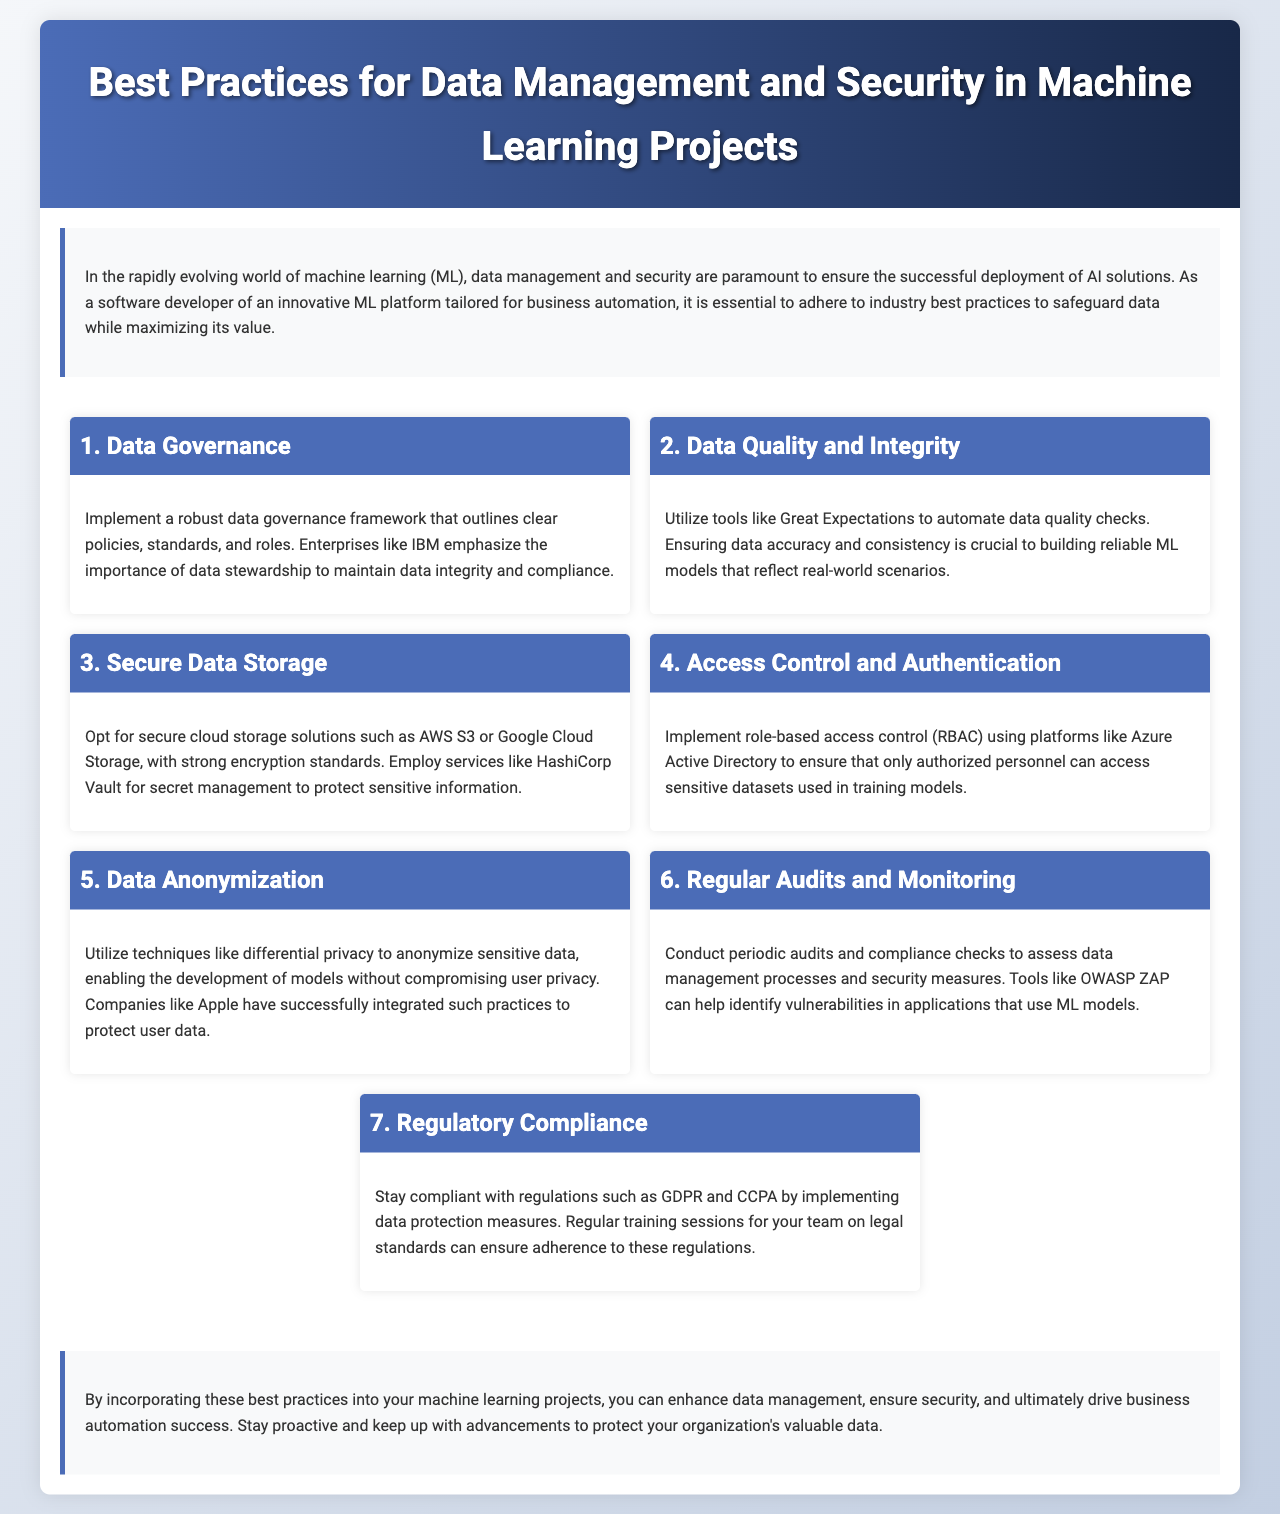What is the title of the brochure? The title is prominently displayed in the header section of the document.
Answer: Best Practices for Data Management and Security in Machine Learning Projects Which section discusses data quality checks? The section explicitly mentions the use of tools for automating data quality checks.
Answer: Data Quality and Integrity What technology is mentioned for secure data storage? The document mentions recognizable cloud storage solutions and their associated encryption standards.
Answer: AWS S3 or Google Cloud Storage What framework is recommended for role-based access control? The document specifies a platform that can be used for implementing access control effectively.
Answer: Azure Active Directory Which privacy technique is mentioned for anonymization? The document provides a specific method for anonymizing sensitive data.
Answer: Differential privacy How many sections are there in total? By counting the distinct topics covered in the content area of the document, you can determine this.
Answer: Seven What is recommended for conducting audits? The document references specific tools that can assist in identifying vulnerabilities during audits.
Answer: OWASP ZAP What compliance regulations should be considered? The document lists two important regulations relevant to data protection.
Answer: GDPR and CCPA 